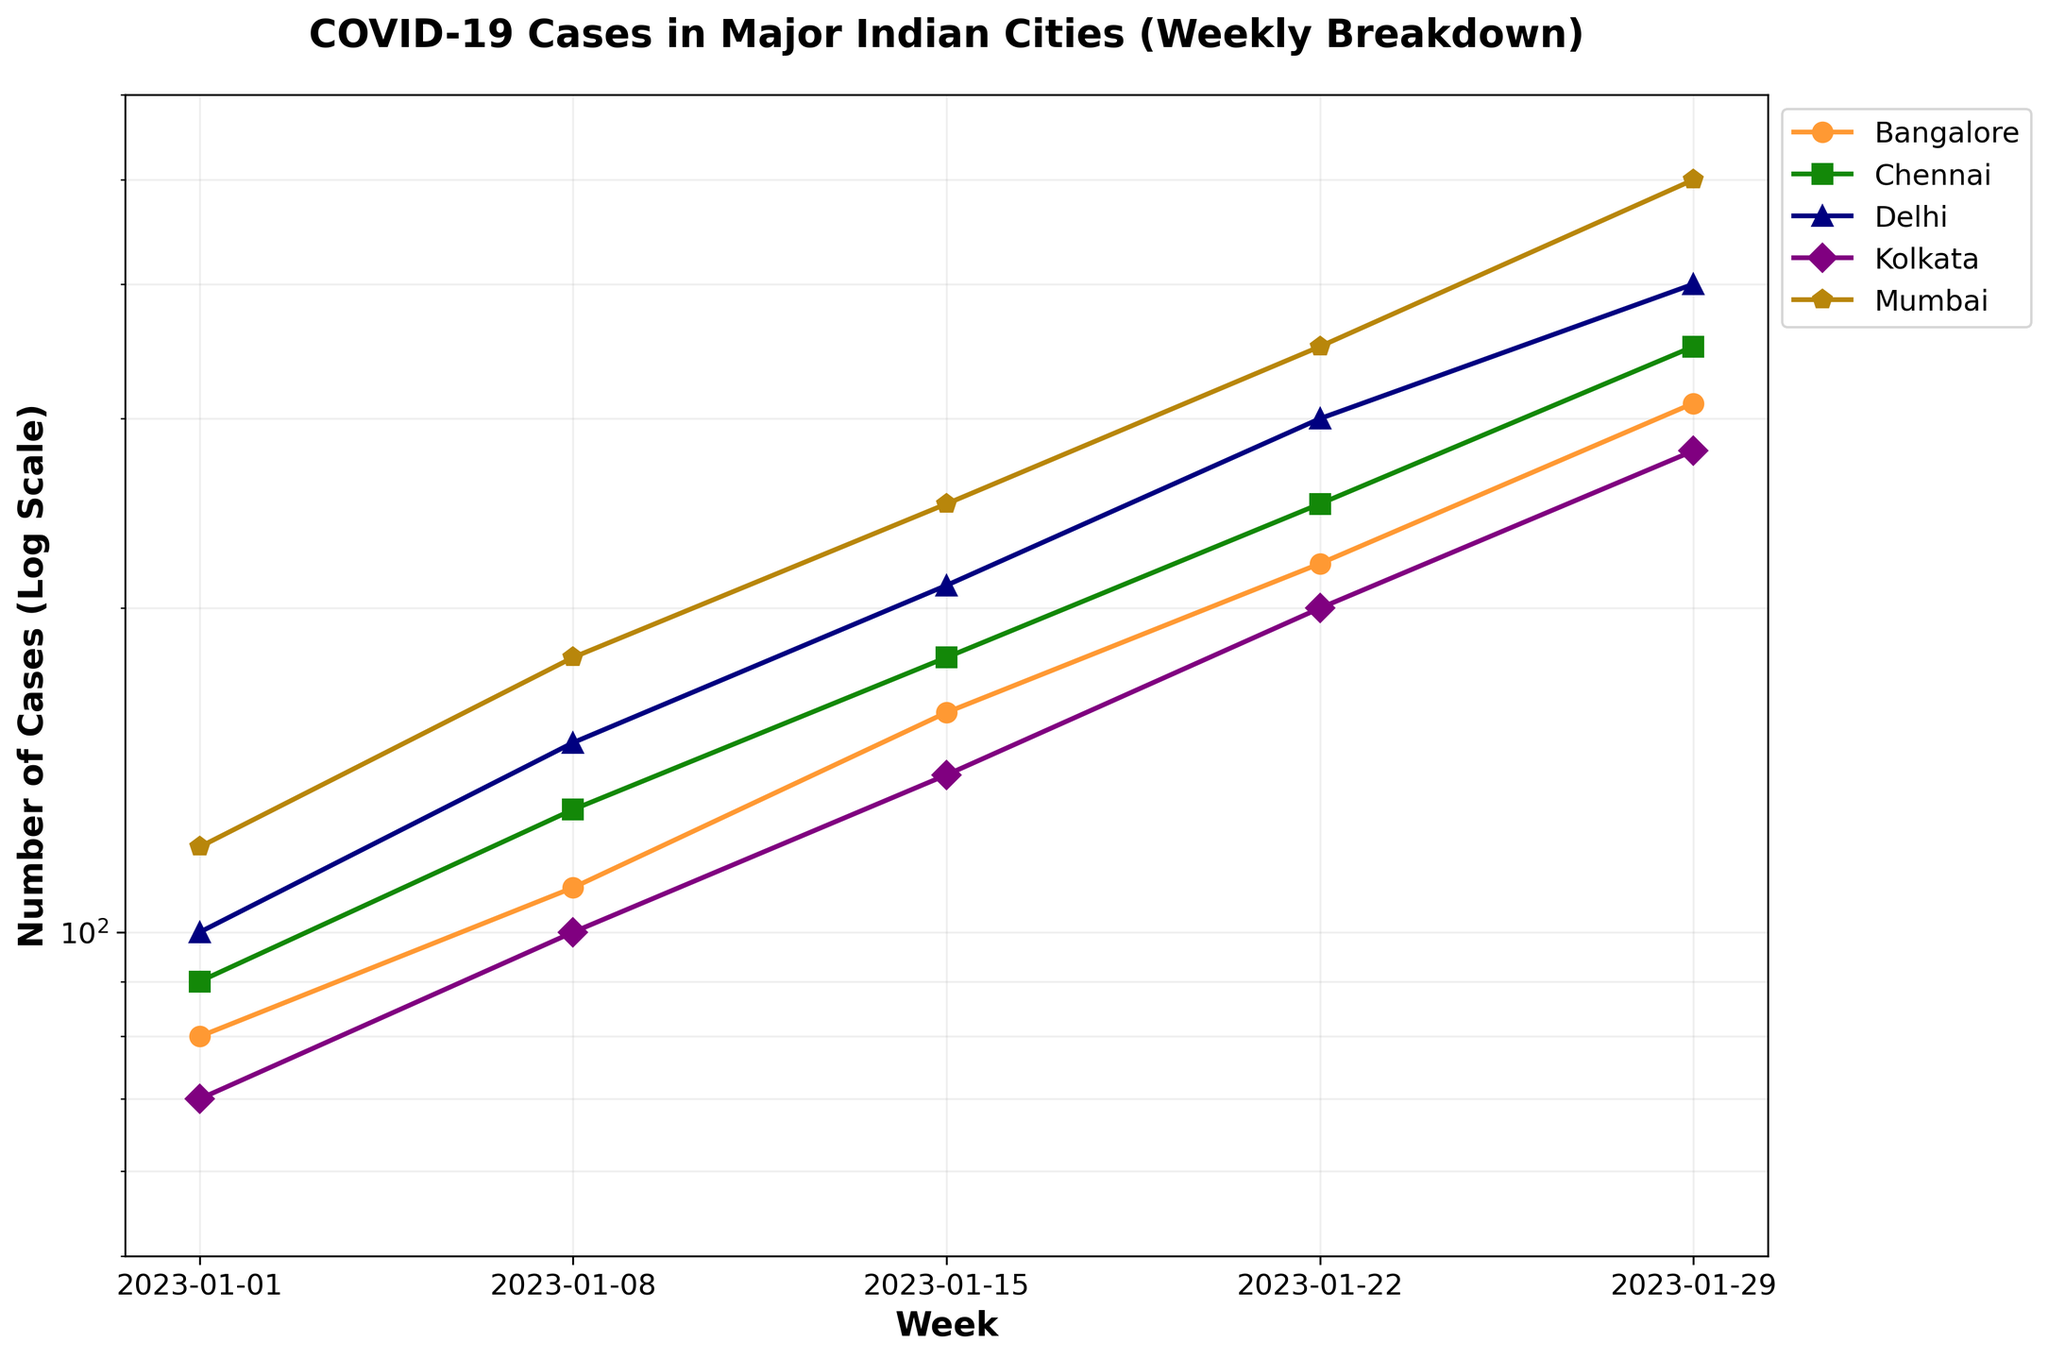How many cities are included in the plot? The legend in the plot shows names of all the cities represented as lines in different colors. By counting these names, the number of cities is determined.
Answer: 5 What is the title of the plot? The title is located at the top center of the plot and it summarizes the contents of the figure.
Answer: COVID-19 Cases in Major Indian Cities (Weekly Breakdown) Which city has the highest number of cases during the last week? Look at the final data points for each city's line on the furthest right side of the plot and compare their values. Mumbai shows the highest value during the last week.
Answer: Mumbai How does the trend of cases in Kolkata compare to other cities over time? By observing the slope and positioning of Kolkata's line relative to other cities, one can see the overall pattern and rate of increase. Kolkata shows a steady rise but has the lowest number among the cities by the end.
Answer: Steady rise, lowest overall Which city shows the steepest increase in cases? By comparing the steepness or angle of ascent of each city's line, you can determine which has the fastest rate of increase. Mumbai and Delhi seem to have the steepest increases.
Answer: Mumbai Which city had the lowest number of cases at the beginning of January 2023? Assess the initial data points (starting at the leftmost side of the plot) for each city and identify the smallest value. Kolkata has the lowest number initially.
Answer: Kolkata Calculate the percentage increase in cases for Chennai from the first to the last week. First calculate the difference in the number of cases from the first (90) to the last week (350). Then, use the formula: ((Final - Initial) / Initial) * 100 to find the percentage increase. ((350 - 90) / 90) * 100 = 288.89%
Answer: 288.89% On the log scale, what is the smallest value displayed on the y-axis? Read the minimum value indicated on the y-axis, which is part of the log scale commonly formatted in powers of 10. The smallest value is around 50.
Answer: 50 Compare the overall trends of Bangalore and Chennai. Are they similar or different? Examine the lines for Bangalore and Chennai on the plot to see if their shapes or rates of increase are comparable. Both show increasing trends, but the rates and final values differ, with Chennai having higher values.
Answer: Different 